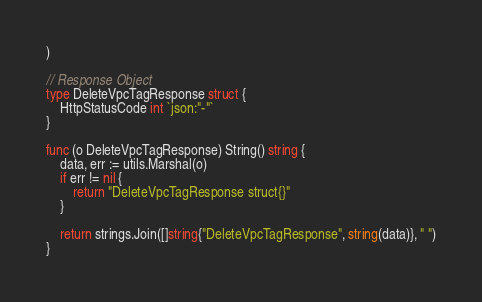Convert code to text. <code><loc_0><loc_0><loc_500><loc_500><_Go_>)

// Response Object
type DeleteVpcTagResponse struct {
	HttpStatusCode int `json:"-"`
}

func (o DeleteVpcTagResponse) String() string {
	data, err := utils.Marshal(o)
	if err != nil {
		return "DeleteVpcTagResponse struct{}"
	}

	return strings.Join([]string{"DeleteVpcTagResponse", string(data)}, " ")
}
</code> 